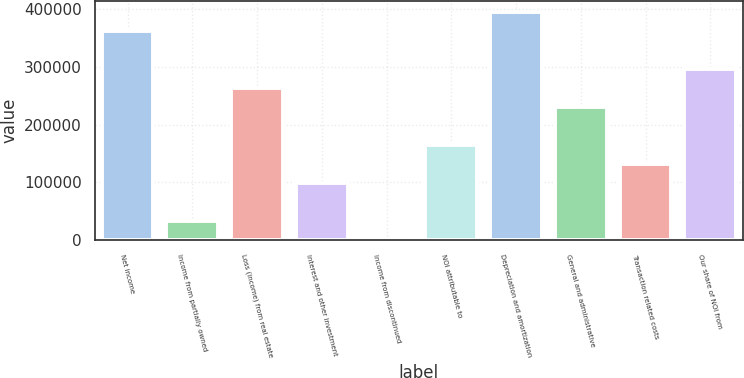<chart> <loc_0><loc_0><loc_500><loc_500><bar_chart><fcel>Net income<fcel>Income from partially owned<fcel>Loss (income) from real estate<fcel>Interest and other investment<fcel>Income from discontinued<fcel>NOI attributable to<fcel>Depreciation and amortization<fcel>General and administrative<fcel>Transaction related costs<fcel>Our share of NOI from<nl><fcel>362458<fcel>33184.4<fcel>263676<fcel>99039.2<fcel>257<fcel>164894<fcel>395386<fcel>230749<fcel>131967<fcel>296604<nl></chart> 